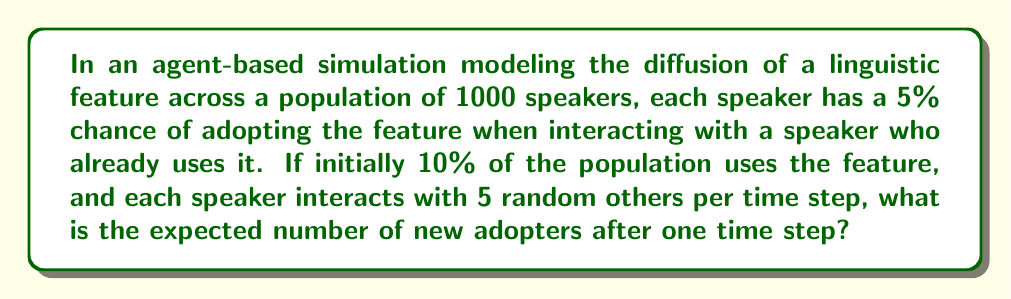Could you help me with this problem? Let's break this down step-by-step:

1) First, we need to determine the number of initial speakers who use the feature:
   $10\% \text{ of } 1000 = 0.1 \times 1000 = 100$ speakers

2) The number of non-adopters at the start:
   $1000 - 100 = 900$ non-adopters

3) Each non-adopter interacts with 5 random speakers. The probability of interacting with at least one adopter is:
   $1 - P(\text{interacting with no adopters})$
   $= 1 - (\frac{900}{1000})^5 = 1 - 0.59049 = 0.40951$

4) Given that a non-adopter interacts with at least one adopter, the probability of adopting the feature is 5% or 0.05.

5) Therefore, the probability of a non-adopter adopting the feature in this time step is:
   $0.40951 \times 0.05 = 0.020475$

6) The expected number of new adopters is this probability multiplied by the number of non-adopters:
   $0.020475 \times 900 = 18.4275$

Thus, the expected number of new adopters after one time step is approximately 18.43.
Answer: 18.43 